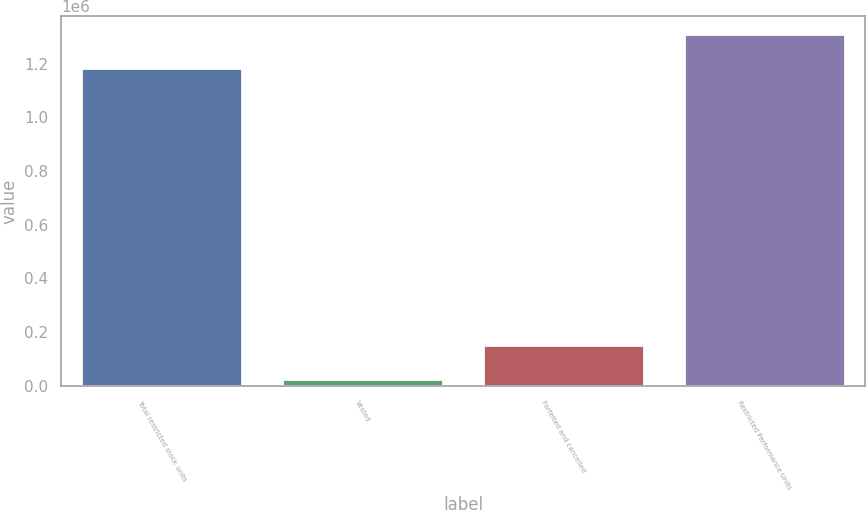Convert chart. <chart><loc_0><loc_0><loc_500><loc_500><bar_chart><fcel>Total restricted stock units<fcel>Vested<fcel>Forfeited and cancelled<fcel>Restricted Performance Units<nl><fcel>1.18508e+06<fcel>24795<fcel>150786<fcel>1.31107e+06<nl></chart> 